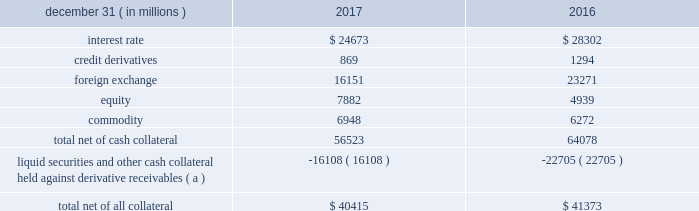Management 2019s discussion and analysis 114 jpmorgan chase & co./2017 annual report derivative contracts in the normal course of business , the firm uses derivative instruments predominantly for market-making activities .
Derivatives enable counterparties to manage exposures to fluctuations in interest rates , currencies and other markets .
The firm also uses derivative instruments to manage its own credit and other market risk exposure .
The nature of the counterparty and the settlement mechanism of the derivative affect the credit risk to which the firm is exposed .
For otc derivatives the firm is exposed to the credit risk of the derivative counterparty .
For exchange- traded derivatives ( 201cetd 201d ) , such as futures and options , and 201ccleared 201d over-the-counter ( 201cotc-cleared 201d ) derivatives , the firm is generally exposed to the credit risk of the relevant ccp .
Where possible , the firm seeks to mitigate its credit risk exposures arising from derivative transactions through the use of legally enforceable master netting arrangements and collateral agreements .
For further discussion of derivative contracts , counterparties and settlement types , see note 5 .
The table summarizes the net derivative receivables for the periods presented .
Derivative receivables .
( a ) includes collateral related to derivative instruments where an appropriate legal opinion has not been either sought or obtained .
Derivative receivables reported on the consolidated balance sheets were $ 56.5 billion and $ 64.1 billion at december 31 , 2017 and 2016 , respectively .
Derivative receivables decreased predominantly as a result of client- driven market-making activities in cib markets , which reduced foreign exchange and interest rate derivative receivables , and increased equity derivative receivables , driven by market movements .
Derivative receivables amounts represent the fair value of the derivative contracts after giving effect to legally enforceable master netting agreements and cash collateral held by the firm .
However , in management 2019s view , the appropriate measure of current credit risk should also take into consideration additional liquid securities ( primarily u.s .
Government and agency securities and other group of seven nations ( 201cg7 201d ) government bonds ) and other cash collateral held by the firm aggregating $ 16.1 billion and $ 22.7 billion at december 31 , 2017 and 2016 , respectively , that may be used as security when the fair value of the client 2019s exposure is in the firm 2019s favor .
In addition to the collateral described in the preceding paragraph , the firm also holds additional collateral ( primarily cash , g7 government securities , other liquid government-agency and guaranteed securities , and corporate debt and equity securities ) delivered by clients at the initiation of transactions , as well as collateral related to contracts that have a non-daily call frequency and collateral that the firm has agreed to return but has not yet settled as of the reporting date .
Although this collateral does not reduce the balances and is not included in the table above , it is available as security against potential exposure that could arise should the fair value of the client 2019s derivative transactions move in the firm 2019s favor .
The derivative receivables fair value , net of all collateral , also does not include other credit enhancements , such as letters of credit .
For additional information on the firm 2019s use of collateral agreements , see note 5 .
While useful as a current view of credit exposure , the net fair value of the derivative receivables does not capture the potential future variability of that credit exposure .
To capture the potential future variability of credit exposure , the firm calculates , on a client-by-client basis , three measures of potential derivatives-related credit loss : peak , derivative risk equivalent ( 201cdre 201d ) , and average exposure ( 201cavg 201d ) .
These measures all incorporate netting and collateral benefits , where applicable .
Peak represents a conservative measure of potential exposure to a counterparty calculated in a manner that is broadly equivalent to a 97.5% ( 97.5 % ) confidence level over the life of the transaction .
Peak is the primary measure used by the firm for setting of credit limits for derivative transactions , senior management reporting and derivatives exposure management .
Dre exposure is a measure that expresses the risk of derivative exposure on a basis intended to be equivalent to the risk of loan exposures .
Dre is a less extreme measure of potential credit loss than peak and is used for aggregating derivative credit risk exposures with loans and other credit risk .
Finally , avg is a measure of the expected fair value of the firm 2019s derivative receivables at future time periods , including the benefit of collateral .
Avg exposure over the total life of the derivative contract is used as the primary metric for pricing purposes and is used to calculate credit risk capital and the cva , as further described below .
The three year avg exposure was $ 29.0 billion and $ 31.1 billion at december 31 , 2017 and 2016 , respectively , compared with derivative receivables , net of all collateral , of $ 40.4 billion and $ 41.4 billion at december 31 , 2017 and 2016 , respectively .
The fair value of the firm 2019s derivative receivables incorporates cva to reflect the credit quality of counterparties .
Cva is based on the firm 2019s avg to a counterparty and the counterparty 2019s credit spread in the credit derivatives market .
The firm believes that active risk management is essential to controlling the dynamic credit risk in the derivatives portfolio .
In addition , the firm 2019s risk management process takes into consideration the potential .
Credit derivatives for 2017 were what percent of the foreign exchange derivatives? 
Computations: (869 / 16151)
Answer: 0.0538. 